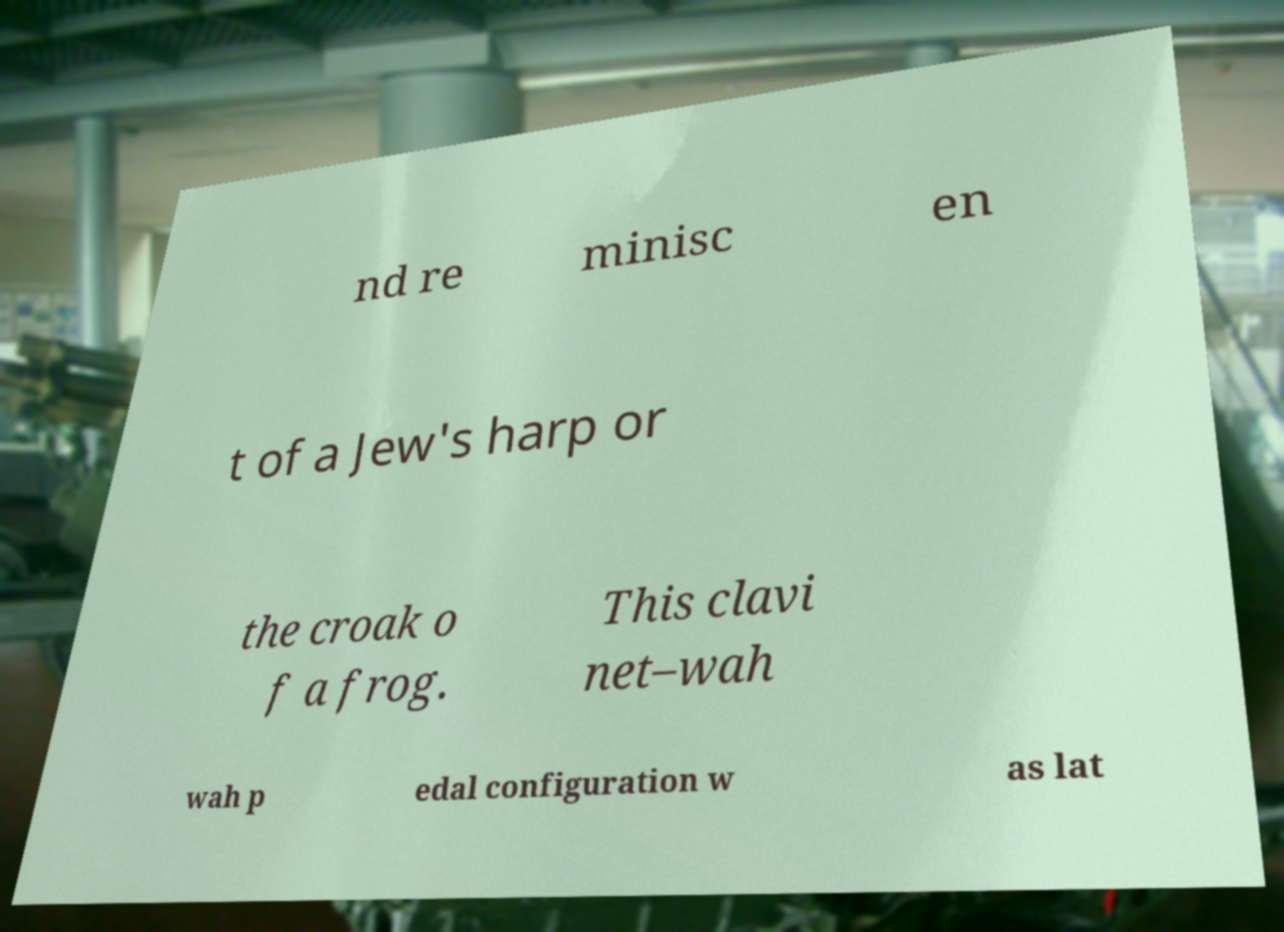For documentation purposes, I need the text within this image transcribed. Could you provide that? nd re minisc en t of a Jew's harp or the croak o f a frog. This clavi net–wah wah p edal configuration w as lat 